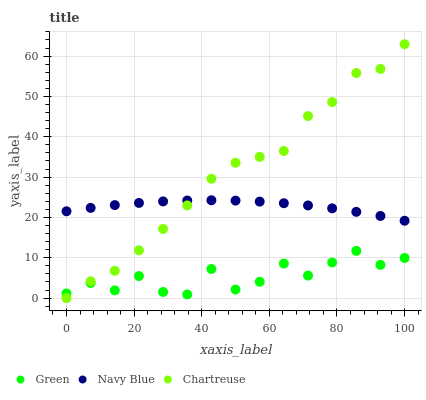Does Green have the minimum area under the curve?
Answer yes or no. Yes. Does Chartreuse have the maximum area under the curve?
Answer yes or no. Yes. Does Chartreuse have the minimum area under the curve?
Answer yes or no. No. Does Green have the maximum area under the curve?
Answer yes or no. No. Is Navy Blue the smoothest?
Answer yes or no. Yes. Is Green the roughest?
Answer yes or no. Yes. Is Chartreuse the smoothest?
Answer yes or no. No. Is Chartreuse the roughest?
Answer yes or no. No. Does Chartreuse have the lowest value?
Answer yes or no. Yes. Does Green have the lowest value?
Answer yes or no. No. Does Chartreuse have the highest value?
Answer yes or no. Yes. Does Green have the highest value?
Answer yes or no. No. Is Green less than Navy Blue?
Answer yes or no. Yes. Is Navy Blue greater than Green?
Answer yes or no. Yes. Does Chartreuse intersect Navy Blue?
Answer yes or no. Yes. Is Chartreuse less than Navy Blue?
Answer yes or no. No. Is Chartreuse greater than Navy Blue?
Answer yes or no. No. Does Green intersect Navy Blue?
Answer yes or no. No. 